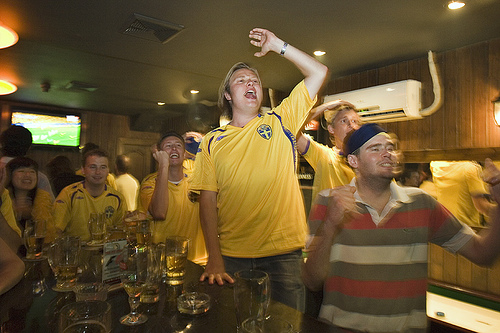<image>
Is the ashtray on the glass? No. The ashtray is not positioned on the glass. They may be near each other, but the ashtray is not supported by or resting on top of the glass. Where is the uncle in relation to the player? Is it in front of the player? Yes. The uncle is positioned in front of the player, appearing closer to the camera viewpoint. 